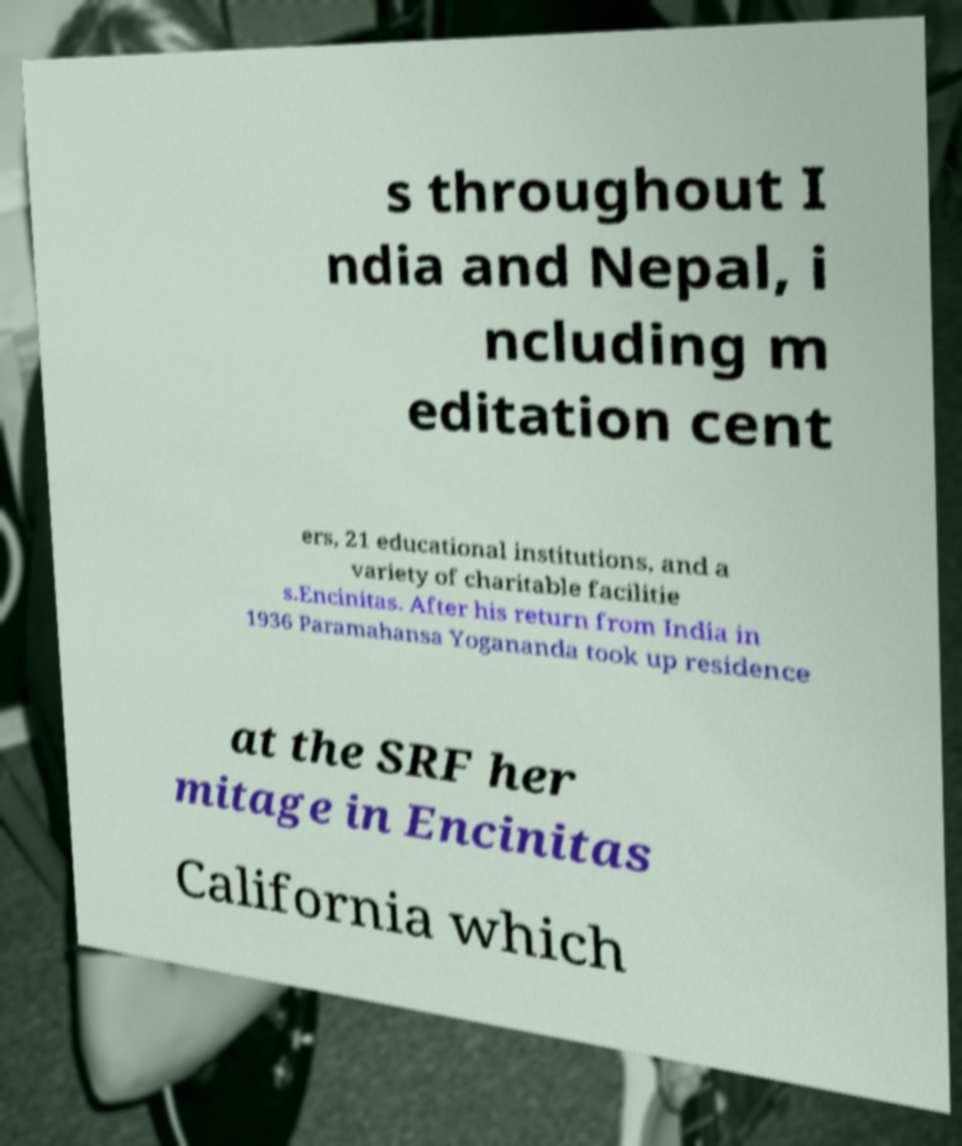What messages or text are displayed in this image? I need them in a readable, typed format. s throughout I ndia and Nepal, i ncluding m editation cent ers, 21 educational institutions, and a variety of charitable facilitie s.Encinitas. After his return from India in 1936 Paramahansa Yogananda took up residence at the SRF her mitage in Encinitas California which 